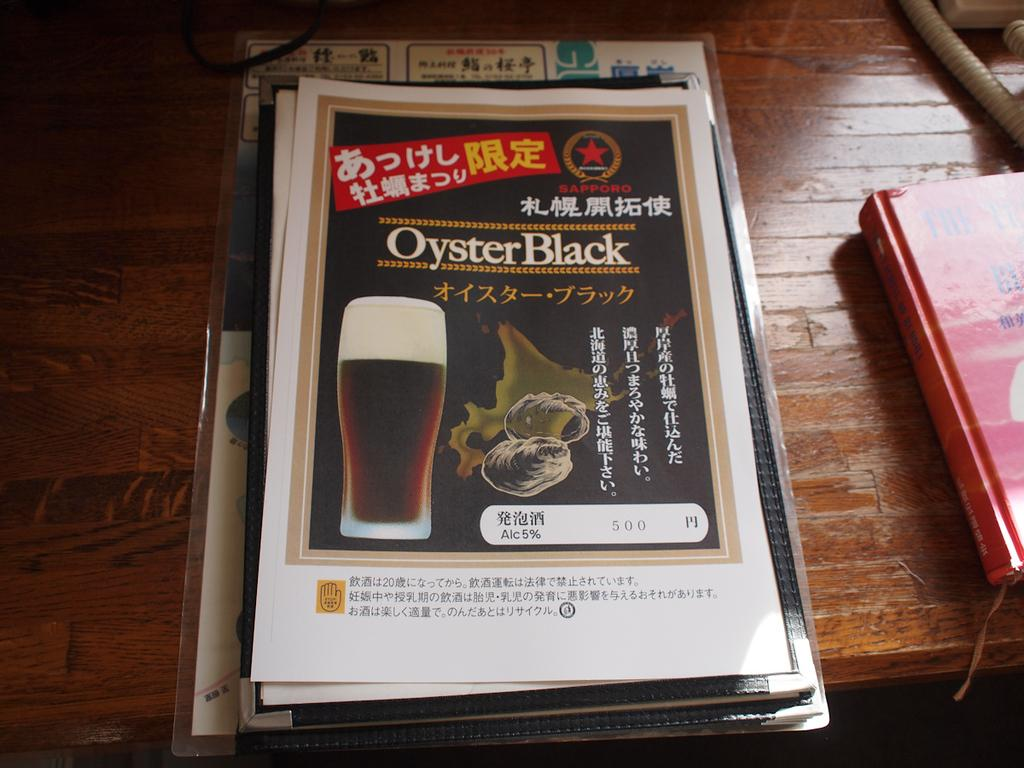<image>
Summarize the visual content of the image. An ad for Oyster Black shows a full glass of beer. 